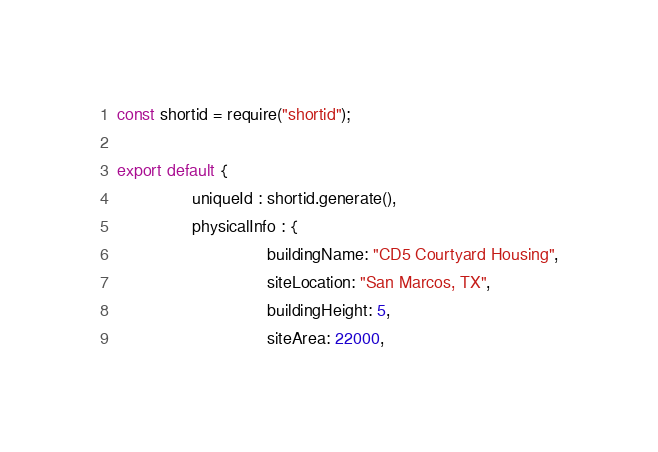Convert code to text. <code><loc_0><loc_0><loc_500><loc_500><_JavaScript_>const shortid = require("shortid");

export default {
				uniqueId : shortid.generate(),
				physicalInfo : {
								buildingName: "CD5 Courtyard Housing",
								siteLocation: "San Marcos, TX",
								buildingHeight: 5,
								siteArea: 22000,</code> 